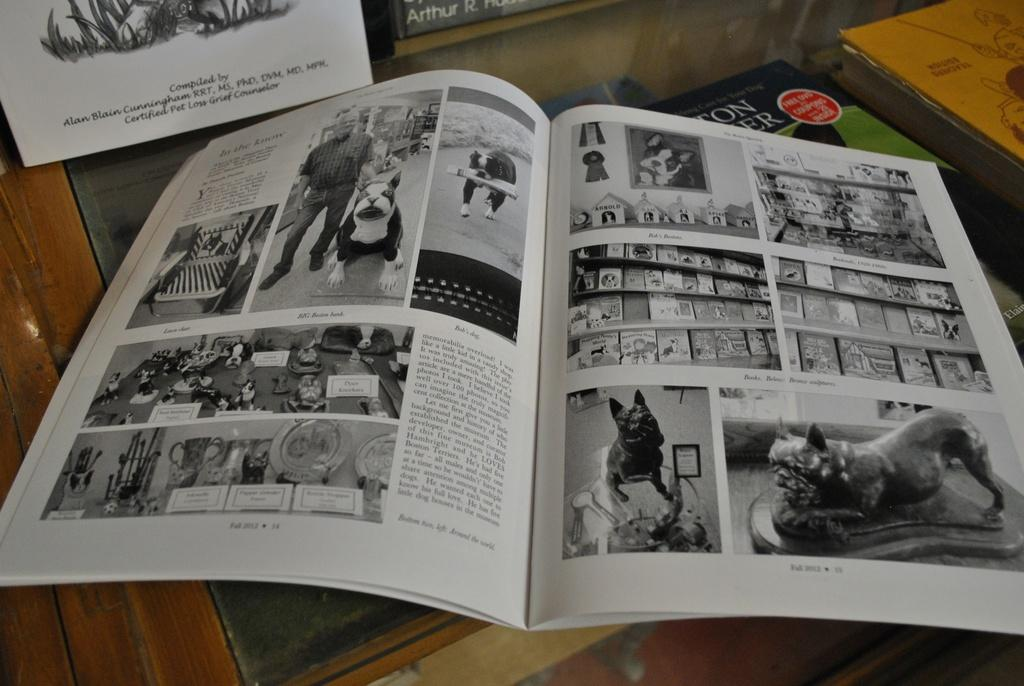<image>
Write a terse but informative summary of the picture. a book open to a page labeled 'fall 2013' at the bottom 